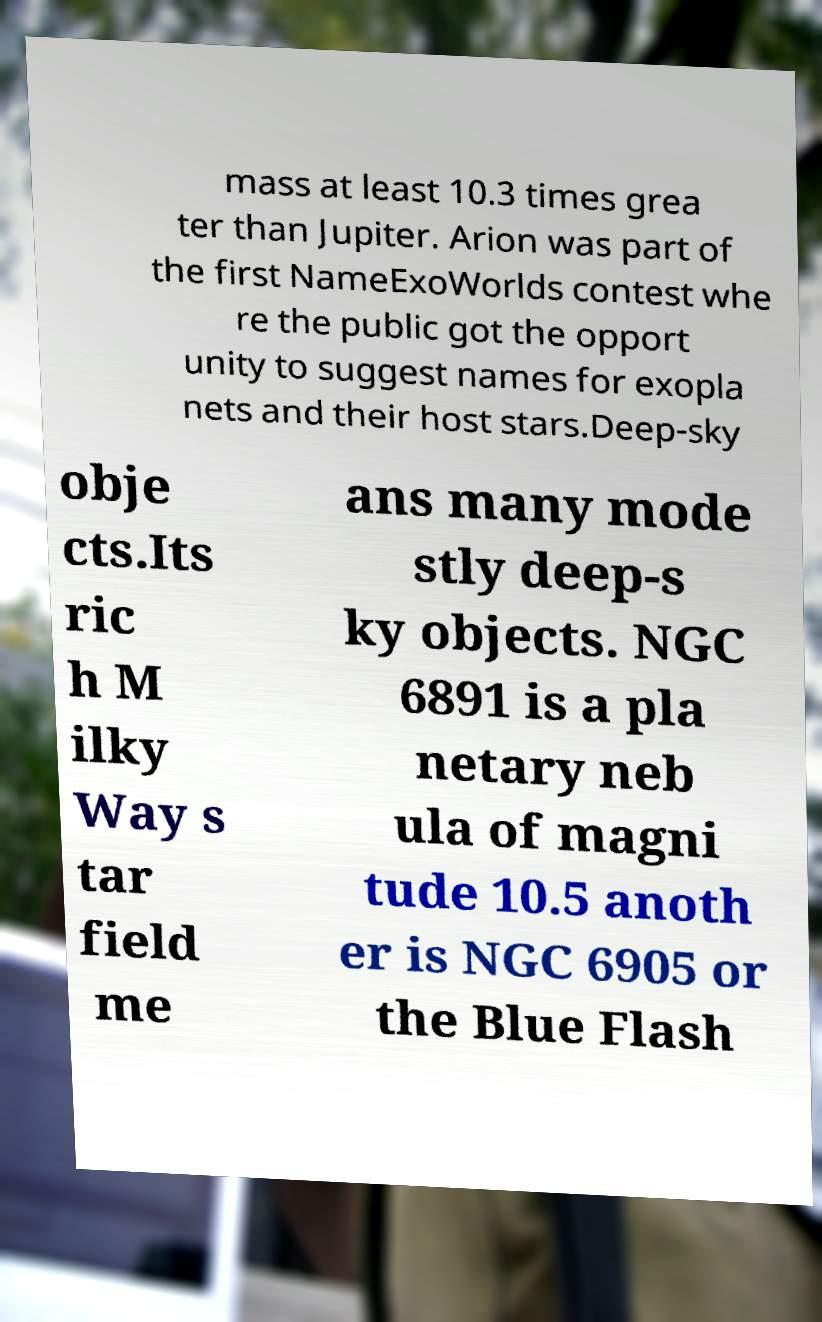Please read and relay the text visible in this image. What does it say? mass at least 10.3 times grea ter than Jupiter. Arion was part of the first NameExoWorlds contest whe re the public got the opport unity to suggest names for exopla nets and their host stars.Deep-sky obje cts.Its ric h M ilky Way s tar field me ans many mode stly deep-s ky objects. NGC 6891 is a pla netary neb ula of magni tude 10.5 anoth er is NGC 6905 or the Blue Flash 